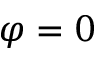Convert formula to latex. <formula><loc_0><loc_0><loc_500><loc_500>\varphi = 0</formula> 